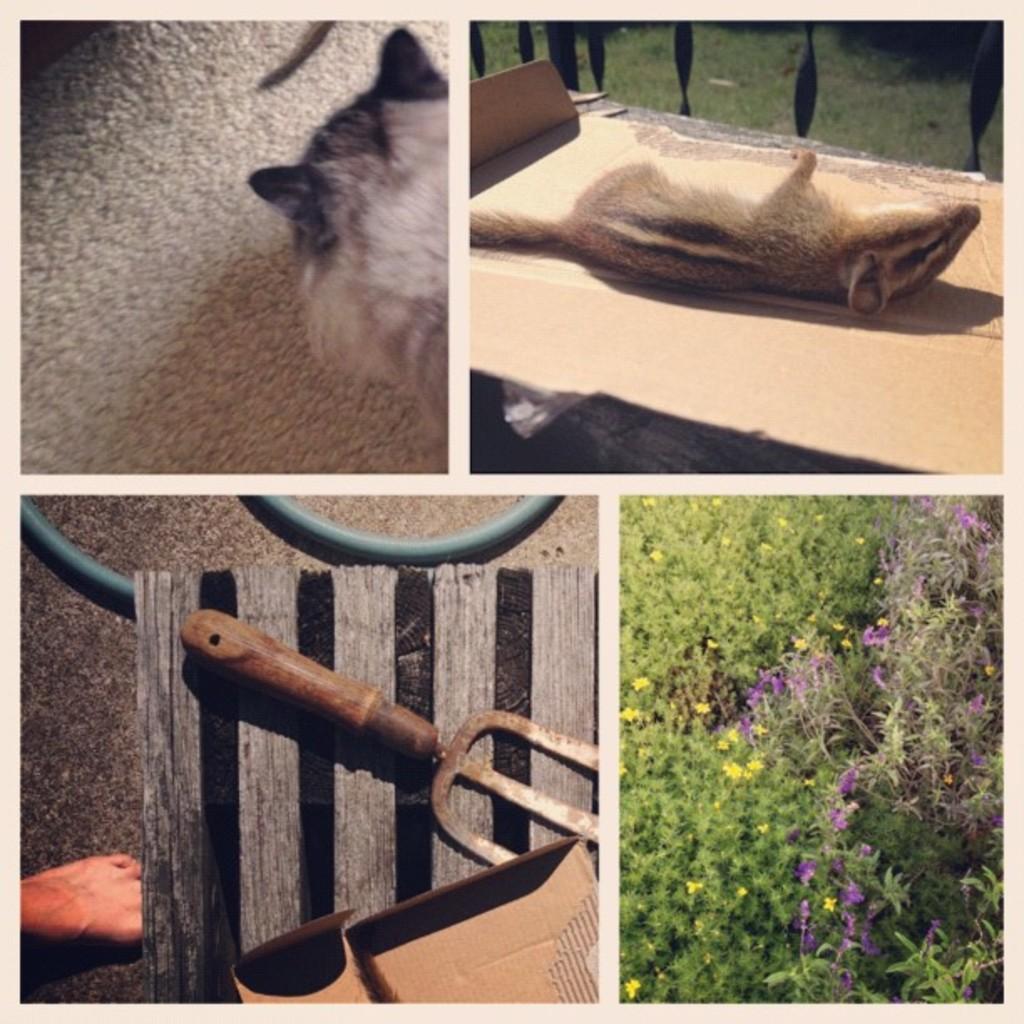Could you give a brief overview of what you see in this image? In this picture we can see a collage photos, In front above there is a cat and on the second image we can see a mouth lying on the cardboard. Down there is a blue color flowers on the plant. 